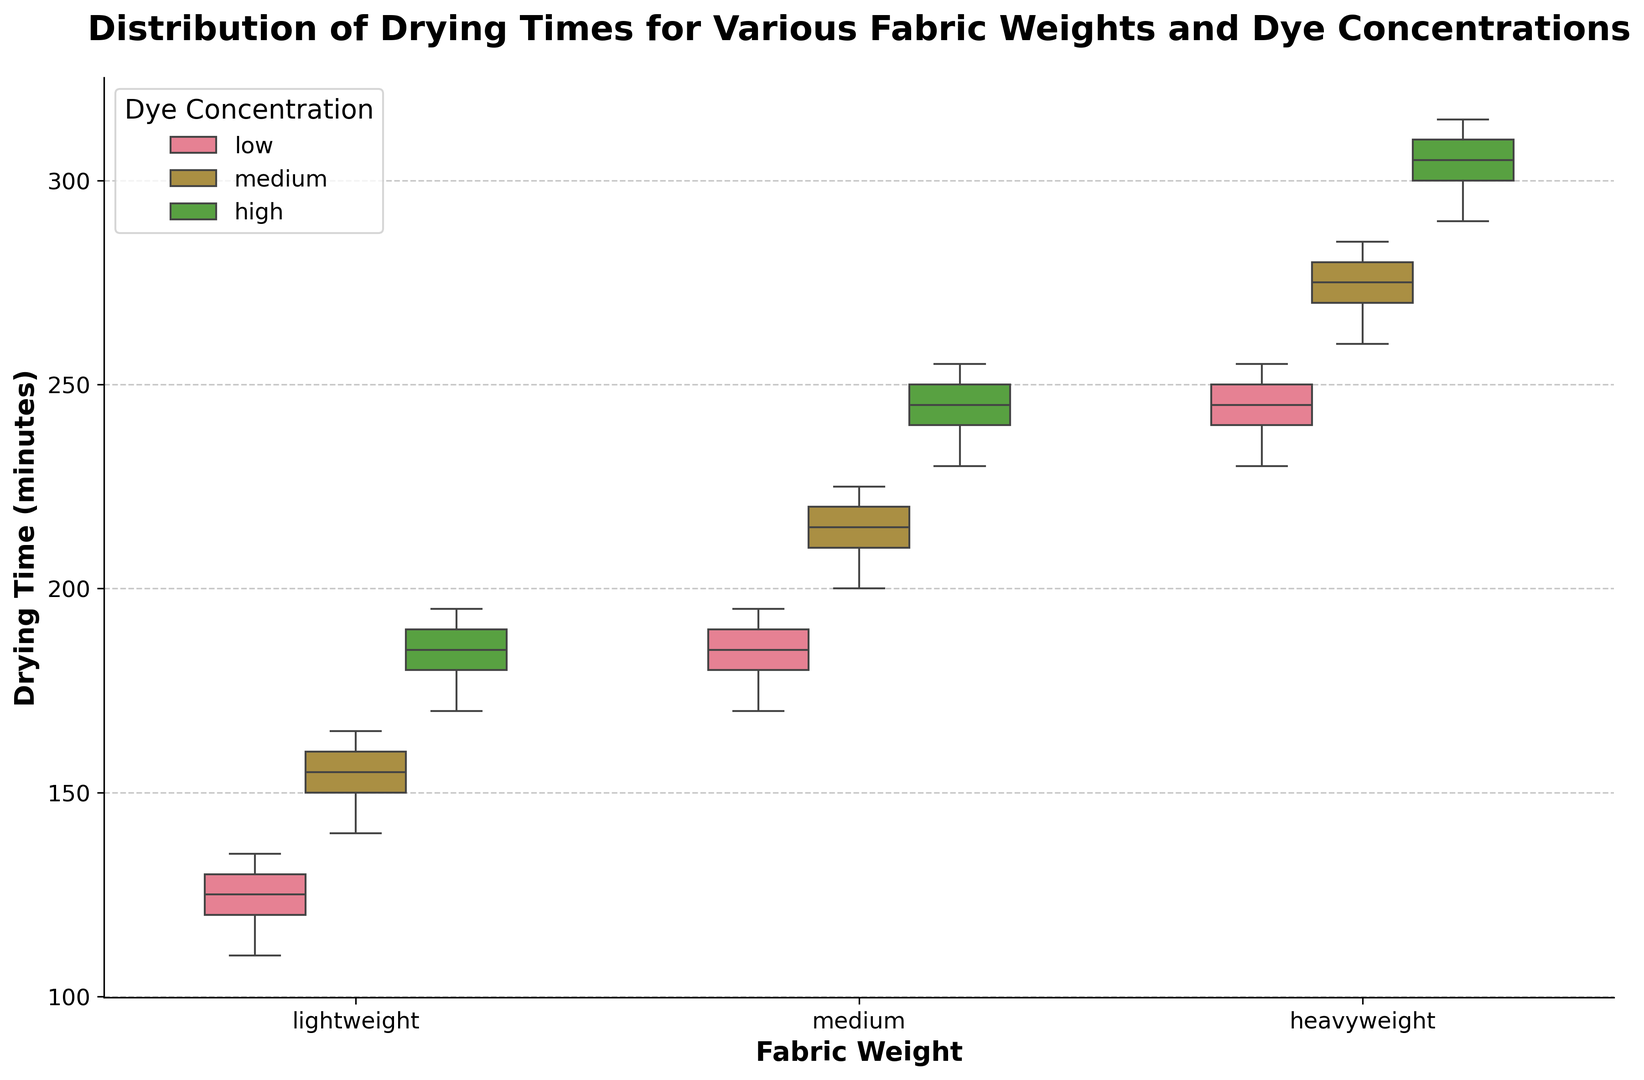What is the median drying time for lightweight fabric with low dye concentration? To find the median drying time for lightweight fabric with low dye concentration, locate the middle value among the drying times, which are: 110, 120, 125, 130, and 135. The median value is the one in the middle, which is 125.
Answer: 125 Which fabric weight and dye concentration combination has the highest median drying time? To find the combination with the highest median drying time, compare the median lines of all the box plots. The combination with the highest median is heavyweight fabric with high dye concentration.
Answer: Heavyweight, high concentration Does medium weight fabric with medium dye concentration have a higher median drying time than heavyweight fabric with low dye concentration? Compare the median lines of the box plots for medium weight fabric with medium dye concentration and heavyweight fabric with low dye concentration. The median for medium weight fabric with medium dye concentration is higher.
Answer: Yes What is the interquartile range (IQR) for medium weight fabric with high dye concentration? The IQR is calculated by finding the difference between the 75th percentile (upper quartile) and the 25th percentile (lower quartile) for the given box plot. For medium weight fabric with high dye concentration, the 25th percentile is 230, and the 75th percentile is 255. Therefore, the IQR = 255 - 230 = 25.
Answer: 25 Which dye concentration generally results in the longest drying times across all fabric weights? Observe the box plots and see which dye concentration typically has the box plots shifted higher on the y-axis. High dye concentration box plots are the highest across all fabric weights.
Answer: High concentration Among lightweight fabrics, which dye concentration has the widest spread in drying times? To determine the widest spread, compare the range (distance from the bottom to top whiskers) of the box plots for all dye concentrations within the lightweight category. The high concentration has the widest spread.
Answer: High concentration Are there any outliers in the drying times for medium weight fabric with low dye concentration? Outliers are typically marked as individual points outside the whiskers of a box plot. Check the box plot for medium weight fabric with low dye concentration to see if there are any such points. There are no outliers.
Answer: No Compare the median drying times for lightweight fabric with medium dye concentration and medium weight fabric with low dye concentration. Which one is higher? Compare the location of the median lines (inside the boxes) for lightweight fabric with medium dye concentration and medium weight fabric with low dye concentration. The median drying time is higher for medium weight fabric with low dye concentration.
Answer: Medium weight, low concentration How does the variability in drying times for heavyweight fabric with medium dye concentration compare to that of medium weight fabric with high dye concentration? Variability can be assessed by comparing the IQRs or the total range (distance from bottom to top whisker) of the box plots. The heavyweight fabric with medium dye concentration has a wider IQR and total range than medium weight fabric with high dye concentration.
Answer: More variability in heavyweight, medium dye concentration 